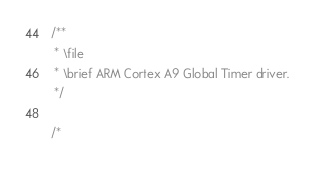Convert code to text. <code><loc_0><loc_0><loc_500><loc_500><_C_>/**
 * \file
 * \brief ARM Cortex A9 Global Timer driver.
 */

/*</code> 